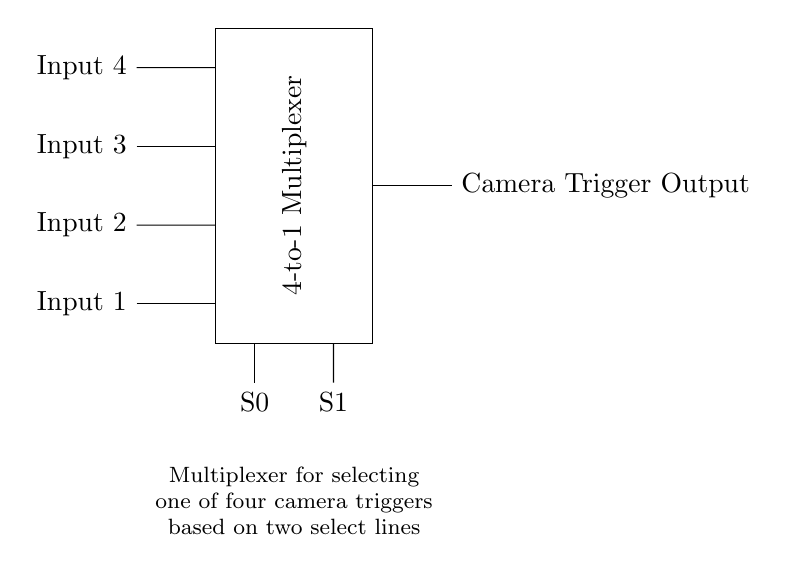What type of multiplexer is shown in the circuit? The circuit displays a 4-to-1 multiplexer, which allows for four input signals to be directed to a single output depending on the select lines.
Answer: 4-to-1 multiplexer How many input lines does this multiplexer accept? The diagram shows four separate input lines labeled Input 1, Input 2, Input 3, and Input 4, indicating the multiplexer accepts four inputs.
Answer: Four What are the select lines labeled in the circuit? The select lines are labeled S0 and S1, which determine which input is sent to the output based on their binary values.
Answer: S0 and S1 What is the purpose of the multiplexer in this circuit? The purpose is to choose one of the four camera triggers based on the states of the select lines, allowing for flexible camera activation.
Answer: Camera trigger selection If S0 is 0 and S1 is 1, which input is selected? With select lines S0 as 0 and S1 as 1, the binary combination corresponds to Input 2 being directed to the output, as it follows the 00, 01, 10, 11 pattern for Input 1 to Input 4.
Answer: Input 2 Which component is responsible for controlling the camera trigger output? The multiplexer directs the selected input to the camera trigger output, making it the component responsible for controlling which camera is triggered based on the selected input.
Answer: The multiplexer 